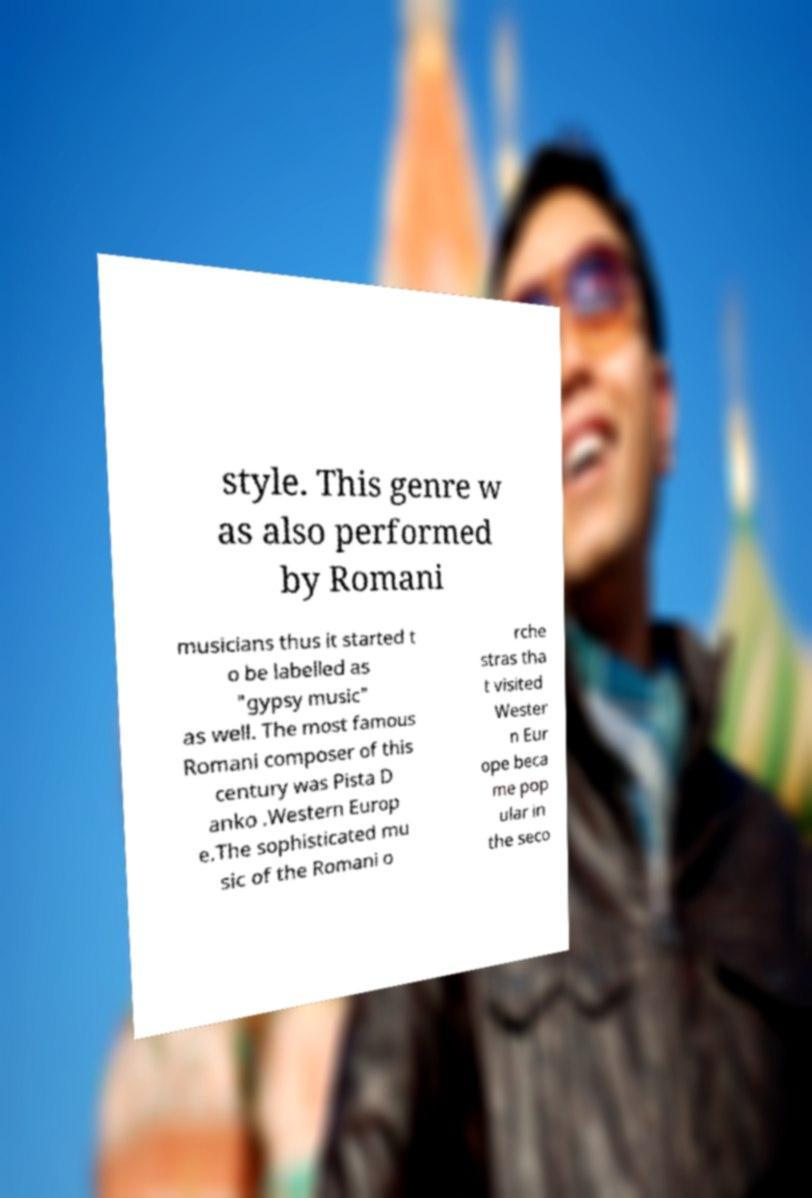Can you read and provide the text displayed in the image?This photo seems to have some interesting text. Can you extract and type it out for me? style. This genre w as also performed by Romani musicians thus it started t o be labelled as "gypsy music" as well. The most famous Romani composer of this century was Pista D anko .Western Europ e.The sophisticated mu sic of the Romani o rche stras tha t visited Wester n Eur ope beca me pop ular in the seco 